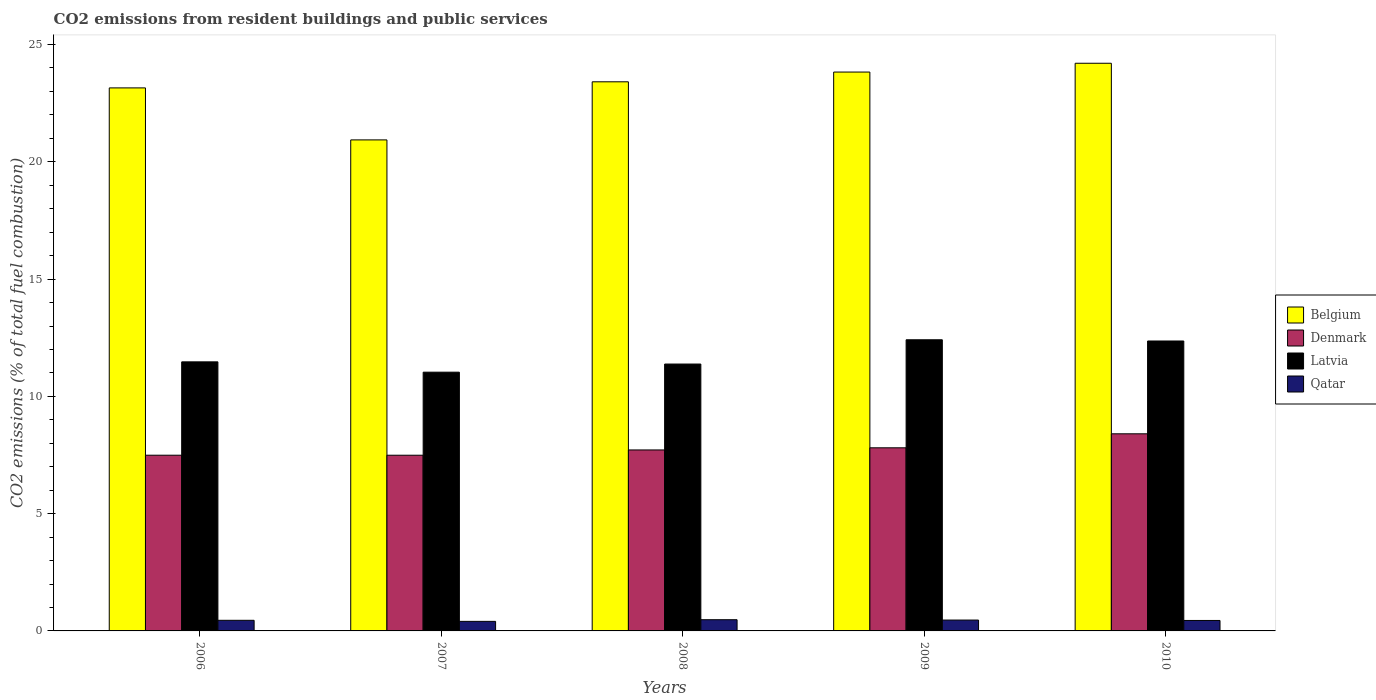How many groups of bars are there?
Keep it short and to the point. 5. Are the number of bars on each tick of the X-axis equal?
Make the answer very short. Yes. How many bars are there on the 3rd tick from the left?
Offer a very short reply. 4. What is the label of the 3rd group of bars from the left?
Provide a succinct answer. 2008. In how many cases, is the number of bars for a given year not equal to the number of legend labels?
Keep it short and to the point. 0. What is the total CO2 emitted in Qatar in 2006?
Provide a short and direct response. 0.45. Across all years, what is the maximum total CO2 emitted in Belgium?
Your answer should be compact. 24.2. Across all years, what is the minimum total CO2 emitted in Latvia?
Make the answer very short. 11.03. In which year was the total CO2 emitted in Belgium maximum?
Keep it short and to the point. 2010. In which year was the total CO2 emitted in Belgium minimum?
Your answer should be compact. 2007. What is the total total CO2 emitted in Denmark in the graph?
Offer a very short reply. 38.91. What is the difference between the total CO2 emitted in Belgium in 2006 and that in 2007?
Your answer should be very brief. 2.22. What is the difference between the total CO2 emitted in Denmark in 2007 and the total CO2 emitted in Belgium in 2010?
Provide a succinct answer. -16.71. What is the average total CO2 emitted in Latvia per year?
Offer a very short reply. 11.73. In the year 2009, what is the difference between the total CO2 emitted in Qatar and total CO2 emitted in Latvia?
Ensure brevity in your answer.  -11.95. In how many years, is the total CO2 emitted in Belgium greater than 11?
Make the answer very short. 5. What is the ratio of the total CO2 emitted in Belgium in 2008 to that in 2010?
Your answer should be very brief. 0.97. What is the difference between the highest and the second highest total CO2 emitted in Belgium?
Offer a very short reply. 0.38. What is the difference between the highest and the lowest total CO2 emitted in Qatar?
Offer a terse response. 0.07. Is the sum of the total CO2 emitted in Denmark in 2007 and 2008 greater than the maximum total CO2 emitted in Latvia across all years?
Your answer should be compact. Yes. Is it the case that in every year, the sum of the total CO2 emitted in Belgium and total CO2 emitted in Denmark is greater than the sum of total CO2 emitted in Latvia and total CO2 emitted in Qatar?
Give a very brief answer. Yes. What does the 4th bar from the left in 2010 represents?
Offer a very short reply. Qatar. What does the 4th bar from the right in 2007 represents?
Your answer should be very brief. Belgium. How many bars are there?
Offer a very short reply. 20. Are all the bars in the graph horizontal?
Your response must be concise. No. How many years are there in the graph?
Your answer should be compact. 5. What is the difference between two consecutive major ticks on the Y-axis?
Your answer should be very brief. 5. Are the values on the major ticks of Y-axis written in scientific E-notation?
Give a very brief answer. No. Does the graph contain grids?
Your response must be concise. No. What is the title of the graph?
Your answer should be very brief. CO2 emissions from resident buildings and public services. Does "El Salvador" appear as one of the legend labels in the graph?
Offer a very short reply. No. What is the label or title of the X-axis?
Ensure brevity in your answer.  Years. What is the label or title of the Y-axis?
Offer a terse response. CO2 emissions (% of total fuel combustion). What is the CO2 emissions (% of total fuel combustion) of Belgium in 2006?
Offer a terse response. 23.15. What is the CO2 emissions (% of total fuel combustion) in Denmark in 2006?
Your answer should be very brief. 7.49. What is the CO2 emissions (% of total fuel combustion) of Latvia in 2006?
Your answer should be compact. 11.47. What is the CO2 emissions (% of total fuel combustion) in Qatar in 2006?
Give a very brief answer. 0.45. What is the CO2 emissions (% of total fuel combustion) in Belgium in 2007?
Offer a very short reply. 20.93. What is the CO2 emissions (% of total fuel combustion) in Denmark in 2007?
Your answer should be very brief. 7.49. What is the CO2 emissions (% of total fuel combustion) of Latvia in 2007?
Your response must be concise. 11.03. What is the CO2 emissions (% of total fuel combustion) in Qatar in 2007?
Your answer should be very brief. 0.41. What is the CO2 emissions (% of total fuel combustion) in Belgium in 2008?
Ensure brevity in your answer.  23.41. What is the CO2 emissions (% of total fuel combustion) in Denmark in 2008?
Keep it short and to the point. 7.72. What is the CO2 emissions (% of total fuel combustion) of Latvia in 2008?
Offer a very short reply. 11.38. What is the CO2 emissions (% of total fuel combustion) in Qatar in 2008?
Keep it short and to the point. 0.48. What is the CO2 emissions (% of total fuel combustion) in Belgium in 2009?
Make the answer very short. 23.83. What is the CO2 emissions (% of total fuel combustion) of Denmark in 2009?
Your response must be concise. 7.81. What is the CO2 emissions (% of total fuel combustion) in Latvia in 2009?
Offer a terse response. 12.41. What is the CO2 emissions (% of total fuel combustion) in Qatar in 2009?
Make the answer very short. 0.46. What is the CO2 emissions (% of total fuel combustion) in Belgium in 2010?
Offer a terse response. 24.2. What is the CO2 emissions (% of total fuel combustion) in Denmark in 2010?
Offer a terse response. 8.4. What is the CO2 emissions (% of total fuel combustion) in Latvia in 2010?
Offer a terse response. 12.36. What is the CO2 emissions (% of total fuel combustion) of Qatar in 2010?
Give a very brief answer. 0.45. Across all years, what is the maximum CO2 emissions (% of total fuel combustion) of Belgium?
Your answer should be compact. 24.2. Across all years, what is the maximum CO2 emissions (% of total fuel combustion) in Denmark?
Your response must be concise. 8.4. Across all years, what is the maximum CO2 emissions (% of total fuel combustion) in Latvia?
Provide a succinct answer. 12.41. Across all years, what is the maximum CO2 emissions (% of total fuel combustion) in Qatar?
Keep it short and to the point. 0.48. Across all years, what is the minimum CO2 emissions (% of total fuel combustion) in Belgium?
Your answer should be compact. 20.93. Across all years, what is the minimum CO2 emissions (% of total fuel combustion) in Denmark?
Provide a short and direct response. 7.49. Across all years, what is the minimum CO2 emissions (% of total fuel combustion) in Latvia?
Give a very brief answer. 11.03. Across all years, what is the minimum CO2 emissions (% of total fuel combustion) of Qatar?
Give a very brief answer. 0.41. What is the total CO2 emissions (% of total fuel combustion) of Belgium in the graph?
Provide a succinct answer. 115.53. What is the total CO2 emissions (% of total fuel combustion) of Denmark in the graph?
Your response must be concise. 38.91. What is the total CO2 emissions (% of total fuel combustion) in Latvia in the graph?
Your answer should be compact. 58.65. What is the total CO2 emissions (% of total fuel combustion) in Qatar in the graph?
Your response must be concise. 2.25. What is the difference between the CO2 emissions (% of total fuel combustion) of Belgium in 2006 and that in 2007?
Your answer should be compact. 2.22. What is the difference between the CO2 emissions (% of total fuel combustion) in Denmark in 2006 and that in 2007?
Your answer should be compact. 0. What is the difference between the CO2 emissions (% of total fuel combustion) of Latvia in 2006 and that in 2007?
Offer a terse response. 0.44. What is the difference between the CO2 emissions (% of total fuel combustion) in Qatar in 2006 and that in 2007?
Ensure brevity in your answer.  0.05. What is the difference between the CO2 emissions (% of total fuel combustion) of Belgium in 2006 and that in 2008?
Keep it short and to the point. -0.26. What is the difference between the CO2 emissions (% of total fuel combustion) of Denmark in 2006 and that in 2008?
Offer a very short reply. -0.22. What is the difference between the CO2 emissions (% of total fuel combustion) in Latvia in 2006 and that in 2008?
Offer a terse response. 0.09. What is the difference between the CO2 emissions (% of total fuel combustion) of Qatar in 2006 and that in 2008?
Provide a succinct answer. -0.03. What is the difference between the CO2 emissions (% of total fuel combustion) in Belgium in 2006 and that in 2009?
Your response must be concise. -0.68. What is the difference between the CO2 emissions (% of total fuel combustion) of Denmark in 2006 and that in 2009?
Your response must be concise. -0.32. What is the difference between the CO2 emissions (% of total fuel combustion) of Latvia in 2006 and that in 2009?
Ensure brevity in your answer.  -0.94. What is the difference between the CO2 emissions (% of total fuel combustion) of Qatar in 2006 and that in 2009?
Give a very brief answer. -0.01. What is the difference between the CO2 emissions (% of total fuel combustion) in Belgium in 2006 and that in 2010?
Provide a succinct answer. -1.05. What is the difference between the CO2 emissions (% of total fuel combustion) of Denmark in 2006 and that in 2010?
Give a very brief answer. -0.91. What is the difference between the CO2 emissions (% of total fuel combustion) in Latvia in 2006 and that in 2010?
Provide a succinct answer. -0.89. What is the difference between the CO2 emissions (% of total fuel combustion) of Qatar in 2006 and that in 2010?
Offer a terse response. 0.01. What is the difference between the CO2 emissions (% of total fuel combustion) in Belgium in 2007 and that in 2008?
Give a very brief answer. -2.48. What is the difference between the CO2 emissions (% of total fuel combustion) in Denmark in 2007 and that in 2008?
Give a very brief answer. -0.23. What is the difference between the CO2 emissions (% of total fuel combustion) of Latvia in 2007 and that in 2008?
Offer a terse response. -0.35. What is the difference between the CO2 emissions (% of total fuel combustion) of Qatar in 2007 and that in 2008?
Your response must be concise. -0.07. What is the difference between the CO2 emissions (% of total fuel combustion) in Belgium in 2007 and that in 2009?
Make the answer very short. -2.89. What is the difference between the CO2 emissions (% of total fuel combustion) in Denmark in 2007 and that in 2009?
Offer a very short reply. -0.32. What is the difference between the CO2 emissions (% of total fuel combustion) in Latvia in 2007 and that in 2009?
Provide a succinct answer. -1.38. What is the difference between the CO2 emissions (% of total fuel combustion) of Qatar in 2007 and that in 2009?
Your answer should be very brief. -0.06. What is the difference between the CO2 emissions (% of total fuel combustion) in Belgium in 2007 and that in 2010?
Your answer should be very brief. -3.27. What is the difference between the CO2 emissions (% of total fuel combustion) of Denmark in 2007 and that in 2010?
Provide a succinct answer. -0.91. What is the difference between the CO2 emissions (% of total fuel combustion) in Latvia in 2007 and that in 2010?
Provide a short and direct response. -1.33. What is the difference between the CO2 emissions (% of total fuel combustion) of Qatar in 2007 and that in 2010?
Offer a terse response. -0.04. What is the difference between the CO2 emissions (% of total fuel combustion) in Belgium in 2008 and that in 2009?
Your response must be concise. -0.42. What is the difference between the CO2 emissions (% of total fuel combustion) of Denmark in 2008 and that in 2009?
Your answer should be very brief. -0.09. What is the difference between the CO2 emissions (% of total fuel combustion) in Latvia in 2008 and that in 2009?
Give a very brief answer. -1.03. What is the difference between the CO2 emissions (% of total fuel combustion) of Qatar in 2008 and that in 2009?
Your answer should be very brief. 0.01. What is the difference between the CO2 emissions (% of total fuel combustion) of Belgium in 2008 and that in 2010?
Offer a very short reply. -0.79. What is the difference between the CO2 emissions (% of total fuel combustion) of Denmark in 2008 and that in 2010?
Give a very brief answer. -0.69. What is the difference between the CO2 emissions (% of total fuel combustion) in Latvia in 2008 and that in 2010?
Make the answer very short. -0.98. What is the difference between the CO2 emissions (% of total fuel combustion) in Qatar in 2008 and that in 2010?
Your response must be concise. 0.03. What is the difference between the CO2 emissions (% of total fuel combustion) in Belgium in 2009 and that in 2010?
Provide a succinct answer. -0.38. What is the difference between the CO2 emissions (% of total fuel combustion) in Denmark in 2009 and that in 2010?
Your response must be concise. -0.6. What is the difference between the CO2 emissions (% of total fuel combustion) of Latvia in 2009 and that in 2010?
Offer a very short reply. 0.05. What is the difference between the CO2 emissions (% of total fuel combustion) of Qatar in 2009 and that in 2010?
Give a very brief answer. 0.02. What is the difference between the CO2 emissions (% of total fuel combustion) of Belgium in 2006 and the CO2 emissions (% of total fuel combustion) of Denmark in 2007?
Your answer should be compact. 15.66. What is the difference between the CO2 emissions (% of total fuel combustion) in Belgium in 2006 and the CO2 emissions (% of total fuel combustion) in Latvia in 2007?
Offer a very short reply. 12.12. What is the difference between the CO2 emissions (% of total fuel combustion) in Belgium in 2006 and the CO2 emissions (% of total fuel combustion) in Qatar in 2007?
Give a very brief answer. 22.74. What is the difference between the CO2 emissions (% of total fuel combustion) of Denmark in 2006 and the CO2 emissions (% of total fuel combustion) of Latvia in 2007?
Give a very brief answer. -3.54. What is the difference between the CO2 emissions (% of total fuel combustion) of Denmark in 2006 and the CO2 emissions (% of total fuel combustion) of Qatar in 2007?
Give a very brief answer. 7.08. What is the difference between the CO2 emissions (% of total fuel combustion) in Latvia in 2006 and the CO2 emissions (% of total fuel combustion) in Qatar in 2007?
Offer a very short reply. 11.06. What is the difference between the CO2 emissions (% of total fuel combustion) in Belgium in 2006 and the CO2 emissions (% of total fuel combustion) in Denmark in 2008?
Keep it short and to the point. 15.44. What is the difference between the CO2 emissions (% of total fuel combustion) of Belgium in 2006 and the CO2 emissions (% of total fuel combustion) of Latvia in 2008?
Keep it short and to the point. 11.77. What is the difference between the CO2 emissions (% of total fuel combustion) of Belgium in 2006 and the CO2 emissions (% of total fuel combustion) of Qatar in 2008?
Ensure brevity in your answer.  22.67. What is the difference between the CO2 emissions (% of total fuel combustion) of Denmark in 2006 and the CO2 emissions (% of total fuel combustion) of Latvia in 2008?
Your answer should be very brief. -3.89. What is the difference between the CO2 emissions (% of total fuel combustion) in Denmark in 2006 and the CO2 emissions (% of total fuel combustion) in Qatar in 2008?
Give a very brief answer. 7.01. What is the difference between the CO2 emissions (% of total fuel combustion) in Latvia in 2006 and the CO2 emissions (% of total fuel combustion) in Qatar in 2008?
Your answer should be very brief. 10.99. What is the difference between the CO2 emissions (% of total fuel combustion) in Belgium in 2006 and the CO2 emissions (% of total fuel combustion) in Denmark in 2009?
Offer a terse response. 15.34. What is the difference between the CO2 emissions (% of total fuel combustion) in Belgium in 2006 and the CO2 emissions (% of total fuel combustion) in Latvia in 2009?
Provide a succinct answer. 10.74. What is the difference between the CO2 emissions (% of total fuel combustion) of Belgium in 2006 and the CO2 emissions (% of total fuel combustion) of Qatar in 2009?
Provide a short and direct response. 22.69. What is the difference between the CO2 emissions (% of total fuel combustion) in Denmark in 2006 and the CO2 emissions (% of total fuel combustion) in Latvia in 2009?
Provide a succinct answer. -4.92. What is the difference between the CO2 emissions (% of total fuel combustion) in Denmark in 2006 and the CO2 emissions (% of total fuel combustion) in Qatar in 2009?
Offer a very short reply. 7.03. What is the difference between the CO2 emissions (% of total fuel combustion) of Latvia in 2006 and the CO2 emissions (% of total fuel combustion) of Qatar in 2009?
Provide a short and direct response. 11.01. What is the difference between the CO2 emissions (% of total fuel combustion) in Belgium in 2006 and the CO2 emissions (% of total fuel combustion) in Denmark in 2010?
Offer a very short reply. 14.75. What is the difference between the CO2 emissions (% of total fuel combustion) of Belgium in 2006 and the CO2 emissions (% of total fuel combustion) of Latvia in 2010?
Your response must be concise. 10.79. What is the difference between the CO2 emissions (% of total fuel combustion) of Belgium in 2006 and the CO2 emissions (% of total fuel combustion) of Qatar in 2010?
Offer a terse response. 22.71. What is the difference between the CO2 emissions (% of total fuel combustion) in Denmark in 2006 and the CO2 emissions (% of total fuel combustion) in Latvia in 2010?
Provide a succinct answer. -4.87. What is the difference between the CO2 emissions (% of total fuel combustion) of Denmark in 2006 and the CO2 emissions (% of total fuel combustion) of Qatar in 2010?
Provide a succinct answer. 7.05. What is the difference between the CO2 emissions (% of total fuel combustion) of Latvia in 2006 and the CO2 emissions (% of total fuel combustion) of Qatar in 2010?
Your response must be concise. 11.03. What is the difference between the CO2 emissions (% of total fuel combustion) of Belgium in 2007 and the CO2 emissions (% of total fuel combustion) of Denmark in 2008?
Make the answer very short. 13.22. What is the difference between the CO2 emissions (% of total fuel combustion) in Belgium in 2007 and the CO2 emissions (% of total fuel combustion) in Latvia in 2008?
Your answer should be compact. 9.56. What is the difference between the CO2 emissions (% of total fuel combustion) of Belgium in 2007 and the CO2 emissions (% of total fuel combustion) of Qatar in 2008?
Your answer should be compact. 20.46. What is the difference between the CO2 emissions (% of total fuel combustion) in Denmark in 2007 and the CO2 emissions (% of total fuel combustion) in Latvia in 2008?
Keep it short and to the point. -3.89. What is the difference between the CO2 emissions (% of total fuel combustion) in Denmark in 2007 and the CO2 emissions (% of total fuel combustion) in Qatar in 2008?
Give a very brief answer. 7.01. What is the difference between the CO2 emissions (% of total fuel combustion) in Latvia in 2007 and the CO2 emissions (% of total fuel combustion) in Qatar in 2008?
Offer a very short reply. 10.55. What is the difference between the CO2 emissions (% of total fuel combustion) of Belgium in 2007 and the CO2 emissions (% of total fuel combustion) of Denmark in 2009?
Make the answer very short. 13.13. What is the difference between the CO2 emissions (% of total fuel combustion) in Belgium in 2007 and the CO2 emissions (% of total fuel combustion) in Latvia in 2009?
Provide a short and direct response. 8.52. What is the difference between the CO2 emissions (% of total fuel combustion) in Belgium in 2007 and the CO2 emissions (% of total fuel combustion) in Qatar in 2009?
Offer a terse response. 20.47. What is the difference between the CO2 emissions (% of total fuel combustion) in Denmark in 2007 and the CO2 emissions (% of total fuel combustion) in Latvia in 2009?
Make the answer very short. -4.92. What is the difference between the CO2 emissions (% of total fuel combustion) of Denmark in 2007 and the CO2 emissions (% of total fuel combustion) of Qatar in 2009?
Provide a succinct answer. 7.03. What is the difference between the CO2 emissions (% of total fuel combustion) in Latvia in 2007 and the CO2 emissions (% of total fuel combustion) in Qatar in 2009?
Your response must be concise. 10.57. What is the difference between the CO2 emissions (% of total fuel combustion) in Belgium in 2007 and the CO2 emissions (% of total fuel combustion) in Denmark in 2010?
Provide a succinct answer. 12.53. What is the difference between the CO2 emissions (% of total fuel combustion) of Belgium in 2007 and the CO2 emissions (% of total fuel combustion) of Latvia in 2010?
Make the answer very short. 8.57. What is the difference between the CO2 emissions (% of total fuel combustion) in Belgium in 2007 and the CO2 emissions (% of total fuel combustion) in Qatar in 2010?
Offer a terse response. 20.49. What is the difference between the CO2 emissions (% of total fuel combustion) in Denmark in 2007 and the CO2 emissions (% of total fuel combustion) in Latvia in 2010?
Ensure brevity in your answer.  -4.87. What is the difference between the CO2 emissions (% of total fuel combustion) of Denmark in 2007 and the CO2 emissions (% of total fuel combustion) of Qatar in 2010?
Your response must be concise. 7.04. What is the difference between the CO2 emissions (% of total fuel combustion) in Latvia in 2007 and the CO2 emissions (% of total fuel combustion) in Qatar in 2010?
Your response must be concise. 10.59. What is the difference between the CO2 emissions (% of total fuel combustion) of Belgium in 2008 and the CO2 emissions (% of total fuel combustion) of Denmark in 2009?
Ensure brevity in your answer.  15.6. What is the difference between the CO2 emissions (% of total fuel combustion) in Belgium in 2008 and the CO2 emissions (% of total fuel combustion) in Latvia in 2009?
Keep it short and to the point. 11. What is the difference between the CO2 emissions (% of total fuel combustion) in Belgium in 2008 and the CO2 emissions (% of total fuel combustion) in Qatar in 2009?
Your answer should be very brief. 22.95. What is the difference between the CO2 emissions (% of total fuel combustion) in Denmark in 2008 and the CO2 emissions (% of total fuel combustion) in Latvia in 2009?
Keep it short and to the point. -4.7. What is the difference between the CO2 emissions (% of total fuel combustion) of Denmark in 2008 and the CO2 emissions (% of total fuel combustion) of Qatar in 2009?
Provide a short and direct response. 7.25. What is the difference between the CO2 emissions (% of total fuel combustion) of Latvia in 2008 and the CO2 emissions (% of total fuel combustion) of Qatar in 2009?
Your answer should be very brief. 10.91. What is the difference between the CO2 emissions (% of total fuel combustion) of Belgium in 2008 and the CO2 emissions (% of total fuel combustion) of Denmark in 2010?
Your response must be concise. 15.01. What is the difference between the CO2 emissions (% of total fuel combustion) in Belgium in 2008 and the CO2 emissions (% of total fuel combustion) in Latvia in 2010?
Give a very brief answer. 11.05. What is the difference between the CO2 emissions (% of total fuel combustion) in Belgium in 2008 and the CO2 emissions (% of total fuel combustion) in Qatar in 2010?
Give a very brief answer. 22.96. What is the difference between the CO2 emissions (% of total fuel combustion) in Denmark in 2008 and the CO2 emissions (% of total fuel combustion) in Latvia in 2010?
Provide a short and direct response. -4.64. What is the difference between the CO2 emissions (% of total fuel combustion) of Denmark in 2008 and the CO2 emissions (% of total fuel combustion) of Qatar in 2010?
Keep it short and to the point. 7.27. What is the difference between the CO2 emissions (% of total fuel combustion) in Latvia in 2008 and the CO2 emissions (% of total fuel combustion) in Qatar in 2010?
Your answer should be very brief. 10.93. What is the difference between the CO2 emissions (% of total fuel combustion) of Belgium in 2009 and the CO2 emissions (% of total fuel combustion) of Denmark in 2010?
Make the answer very short. 15.42. What is the difference between the CO2 emissions (% of total fuel combustion) of Belgium in 2009 and the CO2 emissions (% of total fuel combustion) of Latvia in 2010?
Make the answer very short. 11.47. What is the difference between the CO2 emissions (% of total fuel combustion) in Belgium in 2009 and the CO2 emissions (% of total fuel combustion) in Qatar in 2010?
Your response must be concise. 23.38. What is the difference between the CO2 emissions (% of total fuel combustion) of Denmark in 2009 and the CO2 emissions (% of total fuel combustion) of Latvia in 2010?
Keep it short and to the point. -4.55. What is the difference between the CO2 emissions (% of total fuel combustion) in Denmark in 2009 and the CO2 emissions (% of total fuel combustion) in Qatar in 2010?
Make the answer very short. 7.36. What is the difference between the CO2 emissions (% of total fuel combustion) in Latvia in 2009 and the CO2 emissions (% of total fuel combustion) in Qatar in 2010?
Provide a short and direct response. 11.97. What is the average CO2 emissions (% of total fuel combustion) of Belgium per year?
Ensure brevity in your answer.  23.11. What is the average CO2 emissions (% of total fuel combustion) of Denmark per year?
Ensure brevity in your answer.  7.78. What is the average CO2 emissions (% of total fuel combustion) of Latvia per year?
Keep it short and to the point. 11.73. What is the average CO2 emissions (% of total fuel combustion) of Qatar per year?
Your answer should be very brief. 0.45. In the year 2006, what is the difference between the CO2 emissions (% of total fuel combustion) of Belgium and CO2 emissions (% of total fuel combustion) of Denmark?
Provide a succinct answer. 15.66. In the year 2006, what is the difference between the CO2 emissions (% of total fuel combustion) of Belgium and CO2 emissions (% of total fuel combustion) of Latvia?
Your answer should be compact. 11.68. In the year 2006, what is the difference between the CO2 emissions (% of total fuel combustion) of Belgium and CO2 emissions (% of total fuel combustion) of Qatar?
Your answer should be very brief. 22.7. In the year 2006, what is the difference between the CO2 emissions (% of total fuel combustion) in Denmark and CO2 emissions (% of total fuel combustion) in Latvia?
Your answer should be very brief. -3.98. In the year 2006, what is the difference between the CO2 emissions (% of total fuel combustion) in Denmark and CO2 emissions (% of total fuel combustion) in Qatar?
Keep it short and to the point. 7.04. In the year 2006, what is the difference between the CO2 emissions (% of total fuel combustion) in Latvia and CO2 emissions (% of total fuel combustion) in Qatar?
Ensure brevity in your answer.  11.02. In the year 2007, what is the difference between the CO2 emissions (% of total fuel combustion) in Belgium and CO2 emissions (% of total fuel combustion) in Denmark?
Give a very brief answer. 13.44. In the year 2007, what is the difference between the CO2 emissions (% of total fuel combustion) in Belgium and CO2 emissions (% of total fuel combustion) in Latvia?
Offer a terse response. 9.9. In the year 2007, what is the difference between the CO2 emissions (% of total fuel combustion) of Belgium and CO2 emissions (% of total fuel combustion) of Qatar?
Keep it short and to the point. 20.53. In the year 2007, what is the difference between the CO2 emissions (% of total fuel combustion) in Denmark and CO2 emissions (% of total fuel combustion) in Latvia?
Offer a terse response. -3.54. In the year 2007, what is the difference between the CO2 emissions (% of total fuel combustion) in Denmark and CO2 emissions (% of total fuel combustion) in Qatar?
Ensure brevity in your answer.  7.08. In the year 2007, what is the difference between the CO2 emissions (% of total fuel combustion) in Latvia and CO2 emissions (% of total fuel combustion) in Qatar?
Your response must be concise. 10.62. In the year 2008, what is the difference between the CO2 emissions (% of total fuel combustion) in Belgium and CO2 emissions (% of total fuel combustion) in Denmark?
Keep it short and to the point. 15.69. In the year 2008, what is the difference between the CO2 emissions (% of total fuel combustion) in Belgium and CO2 emissions (% of total fuel combustion) in Latvia?
Provide a short and direct response. 12.03. In the year 2008, what is the difference between the CO2 emissions (% of total fuel combustion) of Belgium and CO2 emissions (% of total fuel combustion) of Qatar?
Offer a terse response. 22.93. In the year 2008, what is the difference between the CO2 emissions (% of total fuel combustion) in Denmark and CO2 emissions (% of total fuel combustion) in Latvia?
Ensure brevity in your answer.  -3.66. In the year 2008, what is the difference between the CO2 emissions (% of total fuel combustion) of Denmark and CO2 emissions (% of total fuel combustion) of Qatar?
Offer a very short reply. 7.24. In the year 2008, what is the difference between the CO2 emissions (% of total fuel combustion) in Latvia and CO2 emissions (% of total fuel combustion) in Qatar?
Your answer should be very brief. 10.9. In the year 2009, what is the difference between the CO2 emissions (% of total fuel combustion) in Belgium and CO2 emissions (% of total fuel combustion) in Denmark?
Offer a terse response. 16.02. In the year 2009, what is the difference between the CO2 emissions (% of total fuel combustion) of Belgium and CO2 emissions (% of total fuel combustion) of Latvia?
Your response must be concise. 11.41. In the year 2009, what is the difference between the CO2 emissions (% of total fuel combustion) of Belgium and CO2 emissions (% of total fuel combustion) of Qatar?
Provide a short and direct response. 23.36. In the year 2009, what is the difference between the CO2 emissions (% of total fuel combustion) in Denmark and CO2 emissions (% of total fuel combustion) in Latvia?
Make the answer very short. -4.61. In the year 2009, what is the difference between the CO2 emissions (% of total fuel combustion) in Denmark and CO2 emissions (% of total fuel combustion) in Qatar?
Provide a succinct answer. 7.34. In the year 2009, what is the difference between the CO2 emissions (% of total fuel combustion) of Latvia and CO2 emissions (% of total fuel combustion) of Qatar?
Make the answer very short. 11.95. In the year 2010, what is the difference between the CO2 emissions (% of total fuel combustion) of Belgium and CO2 emissions (% of total fuel combustion) of Denmark?
Offer a very short reply. 15.8. In the year 2010, what is the difference between the CO2 emissions (% of total fuel combustion) in Belgium and CO2 emissions (% of total fuel combustion) in Latvia?
Keep it short and to the point. 11.84. In the year 2010, what is the difference between the CO2 emissions (% of total fuel combustion) in Belgium and CO2 emissions (% of total fuel combustion) in Qatar?
Ensure brevity in your answer.  23.76. In the year 2010, what is the difference between the CO2 emissions (% of total fuel combustion) in Denmark and CO2 emissions (% of total fuel combustion) in Latvia?
Keep it short and to the point. -3.96. In the year 2010, what is the difference between the CO2 emissions (% of total fuel combustion) in Denmark and CO2 emissions (% of total fuel combustion) in Qatar?
Offer a terse response. 7.96. In the year 2010, what is the difference between the CO2 emissions (% of total fuel combustion) in Latvia and CO2 emissions (% of total fuel combustion) in Qatar?
Provide a short and direct response. 11.92. What is the ratio of the CO2 emissions (% of total fuel combustion) of Belgium in 2006 to that in 2007?
Your response must be concise. 1.11. What is the ratio of the CO2 emissions (% of total fuel combustion) in Denmark in 2006 to that in 2007?
Offer a terse response. 1. What is the ratio of the CO2 emissions (% of total fuel combustion) of Latvia in 2006 to that in 2007?
Your answer should be compact. 1.04. What is the ratio of the CO2 emissions (% of total fuel combustion) of Qatar in 2006 to that in 2007?
Ensure brevity in your answer.  1.11. What is the ratio of the CO2 emissions (% of total fuel combustion) in Belgium in 2006 to that in 2008?
Provide a short and direct response. 0.99. What is the ratio of the CO2 emissions (% of total fuel combustion) of Denmark in 2006 to that in 2008?
Your answer should be very brief. 0.97. What is the ratio of the CO2 emissions (% of total fuel combustion) of Latvia in 2006 to that in 2008?
Provide a short and direct response. 1.01. What is the ratio of the CO2 emissions (% of total fuel combustion) in Qatar in 2006 to that in 2008?
Give a very brief answer. 0.95. What is the ratio of the CO2 emissions (% of total fuel combustion) in Belgium in 2006 to that in 2009?
Offer a very short reply. 0.97. What is the ratio of the CO2 emissions (% of total fuel combustion) in Denmark in 2006 to that in 2009?
Your response must be concise. 0.96. What is the ratio of the CO2 emissions (% of total fuel combustion) in Latvia in 2006 to that in 2009?
Your response must be concise. 0.92. What is the ratio of the CO2 emissions (% of total fuel combustion) of Qatar in 2006 to that in 2009?
Make the answer very short. 0.98. What is the ratio of the CO2 emissions (% of total fuel combustion) of Belgium in 2006 to that in 2010?
Your answer should be compact. 0.96. What is the ratio of the CO2 emissions (% of total fuel combustion) in Denmark in 2006 to that in 2010?
Your answer should be compact. 0.89. What is the ratio of the CO2 emissions (% of total fuel combustion) in Latvia in 2006 to that in 2010?
Your answer should be very brief. 0.93. What is the ratio of the CO2 emissions (% of total fuel combustion) in Qatar in 2006 to that in 2010?
Keep it short and to the point. 1.02. What is the ratio of the CO2 emissions (% of total fuel combustion) of Belgium in 2007 to that in 2008?
Give a very brief answer. 0.89. What is the ratio of the CO2 emissions (% of total fuel combustion) of Denmark in 2007 to that in 2008?
Your answer should be very brief. 0.97. What is the ratio of the CO2 emissions (% of total fuel combustion) in Latvia in 2007 to that in 2008?
Keep it short and to the point. 0.97. What is the ratio of the CO2 emissions (% of total fuel combustion) of Qatar in 2007 to that in 2008?
Offer a very short reply. 0.85. What is the ratio of the CO2 emissions (% of total fuel combustion) of Belgium in 2007 to that in 2009?
Make the answer very short. 0.88. What is the ratio of the CO2 emissions (% of total fuel combustion) in Denmark in 2007 to that in 2009?
Offer a very short reply. 0.96. What is the ratio of the CO2 emissions (% of total fuel combustion) of Latvia in 2007 to that in 2009?
Ensure brevity in your answer.  0.89. What is the ratio of the CO2 emissions (% of total fuel combustion) in Qatar in 2007 to that in 2009?
Make the answer very short. 0.88. What is the ratio of the CO2 emissions (% of total fuel combustion) of Belgium in 2007 to that in 2010?
Offer a terse response. 0.86. What is the ratio of the CO2 emissions (% of total fuel combustion) in Denmark in 2007 to that in 2010?
Offer a terse response. 0.89. What is the ratio of the CO2 emissions (% of total fuel combustion) of Latvia in 2007 to that in 2010?
Ensure brevity in your answer.  0.89. What is the ratio of the CO2 emissions (% of total fuel combustion) in Qatar in 2007 to that in 2010?
Provide a short and direct response. 0.91. What is the ratio of the CO2 emissions (% of total fuel combustion) of Belgium in 2008 to that in 2009?
Your answer should be compact. 0.98. What is the ratio of the CO2 emissions (% of total fuel combustion) of Denmark in 2008 to that in 2009?
Provide a succinct answer. 0.99. What is the ratio of the CO2 emissions (% of total fuel combustion) in Latvia in 2008 to that in 2009?
Offer a very short reply. 0.92. What is the ratio of the CO2 emissions (% of total fuel combustion) in Qatar in 2008 to that in 2009?
Your answer should be very brief. 1.03. What is the ratio of the CO2 emissions (% of total fuel combustion) in Belgium in 2008 to that in 2010?
Your response must be concise. 0.97. What is the ratio of the CO2 emissions (% of total fuel combustion) of Denmark in 2008 to that in 2010?
Ensure brevity in your answer.  0.92. What is the ratio of the CO2 emissions (% of total fuel combustion) in Latvia in 2008 to that in 2010?
Provide a short and direct response. 0.92. What is the ratio of the CO2 emissions (% of total fuel combustion) of Qatar in 2008 to that in 2010?
Make the answer very short. 1.07. What is the ratio of the CO2 emissions (% of total fuel combustion) of Belgium in 2009 to that in 2010?
Your answer should be compact. 0.98. What is the ratio of the CO2 emissions (% of total fuel combustion) in Denmark in 2009 to that in 2010?
Offer a terse response. 0.93. What is the ratio of the CO2 emissions (% of total fuel combustion) in Latvia in 2009 to that in 2010?
Ensure brevity in your answer.  1. What is the ratio of the CO2 emissions (% of total fuel combustion) in Qatar in 2009 to that in 2010?
Keep it short and to the point. 1.04. What is the difference between the highest and the second highest CO2 emissions (% of total fuel combustion) in Belgium?
Give a very brief answer. 0.38. What is the difference between the highest and the second highest CO2 emissions (% of total fuel combustion) of Denmark?
Offer a very short reply. 0.6. What is the difference between the highest and the second highest CO2 emissions (% of total fuel combustion) of Latvia?
Make the answer very short. 0.05. What is the difference between the highest and the second highest CO2 emissions (% of total fuel combustion) of Qatar?
Make the answer very short. 0.01. What is the difference between the highest and the lowest CO2 emissions (% of total fuel combustion) of Belgium?
Make the answer very short. 3.27. What is the difference between the highest and the lowest CO2 emissions (% of total fuel combustion) in Denmark?
Keep it short and to the point. 0.91. What is the difference between the highest and the lowest CO2 emissions (% of total fuel combustion) in Latvia?
Provide a short and direct response. 1.38. What is the difference between the highest and the lowest CO2 emissions (% of total fuel combustion) of Qatar?
Offer a terse response. 0.07. 